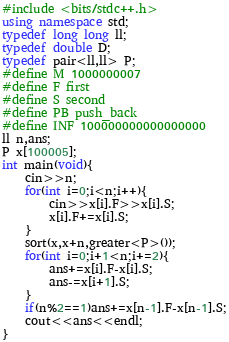Convert code to text. <code><loc_0><loc_0><loc_500><loc_500><_C++_>#include <bits/stdc++.h>
using namespace std;
typedef long long ll;
typedef double D;
typedef pair<ll,ll> P;
#define M 1000000007
#define F first
#define S second
#define PB push_back
#define INF 100000000000000000
ll n,ans;
P x[100005];
int main(void){
	cin>>n;
	for(int i=0;i<n;i++){
		cin>>x[i].F>>x[i].S;
		x[i].F+=x[i].S;
	}
	sort(x,x+n,greater<P>());
	for(int i=0;i+1<n;i+=2){
		ans+=x[i].F-x[i].S;
		ans-=x[i+1].S;
	}
	if(n%2==1)ans+=x[n-1].F-x[n-1].S;
	cout<<ans<<endl;
}</code> 